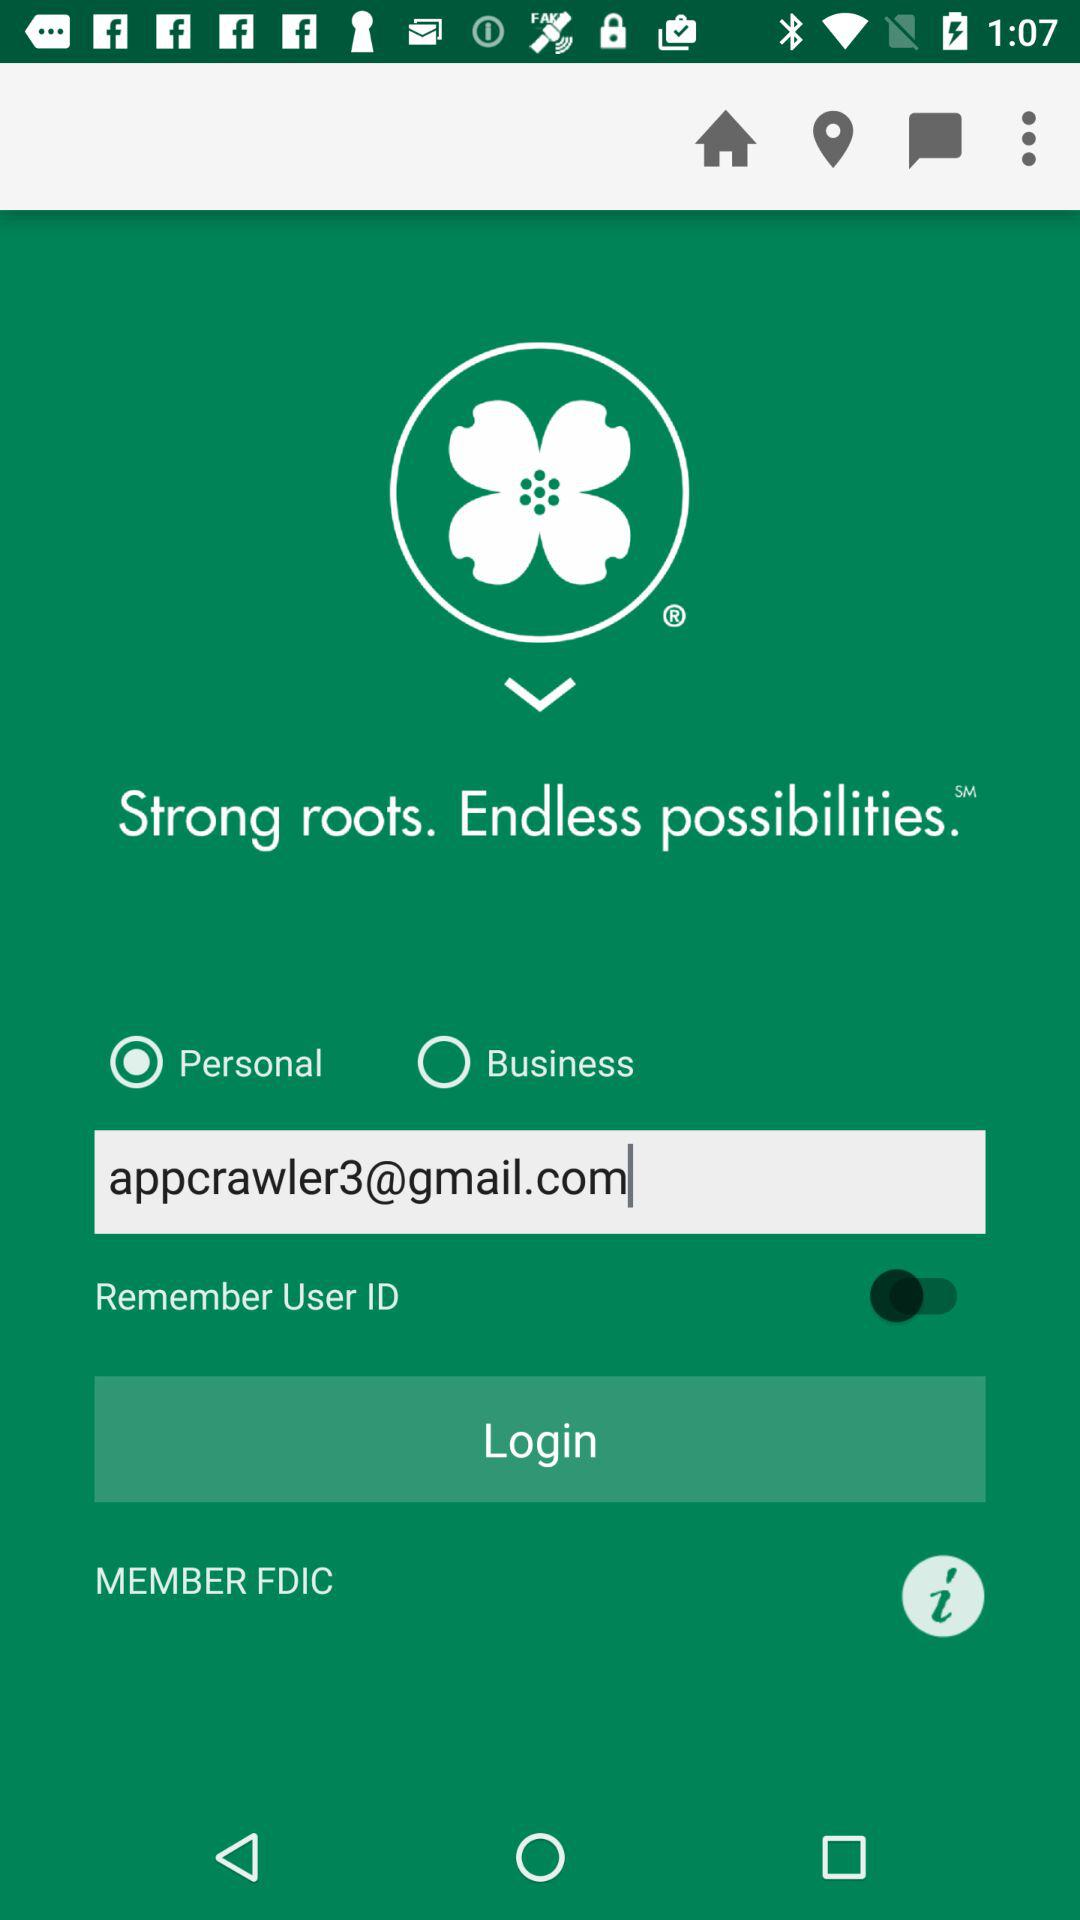Which option is selected? The selected option is "Personal". 